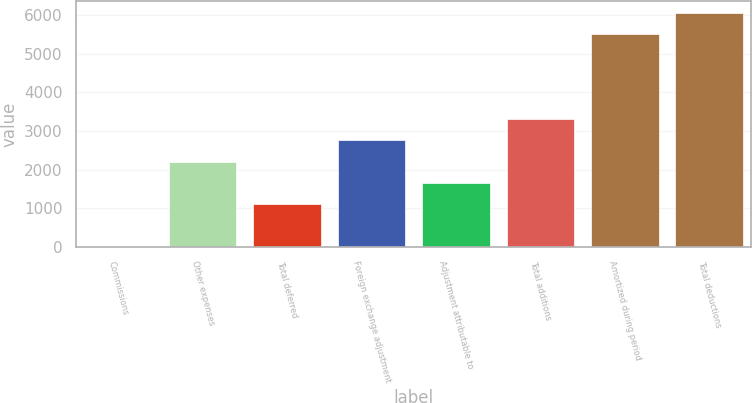Convert chart to OTSL. <chart><loc_0><loc_0><loc_500><loc_500><bar_chart><fcel>Commissions<fcel>Other expenses<fcel>Total deferred<fcel>Foreign exchange adjustment<fcel>Adjustment attributable to<fcel>Total additions<fcel>Amortized during period<fcel>Total deductions<nl><fcel>1.01<fcel>2201.01<fcel>1101.01<fcel>2751.01<fcel>1651.01<fcel>3301.01<fcel>5501<fcel>6051<nl></chart> 